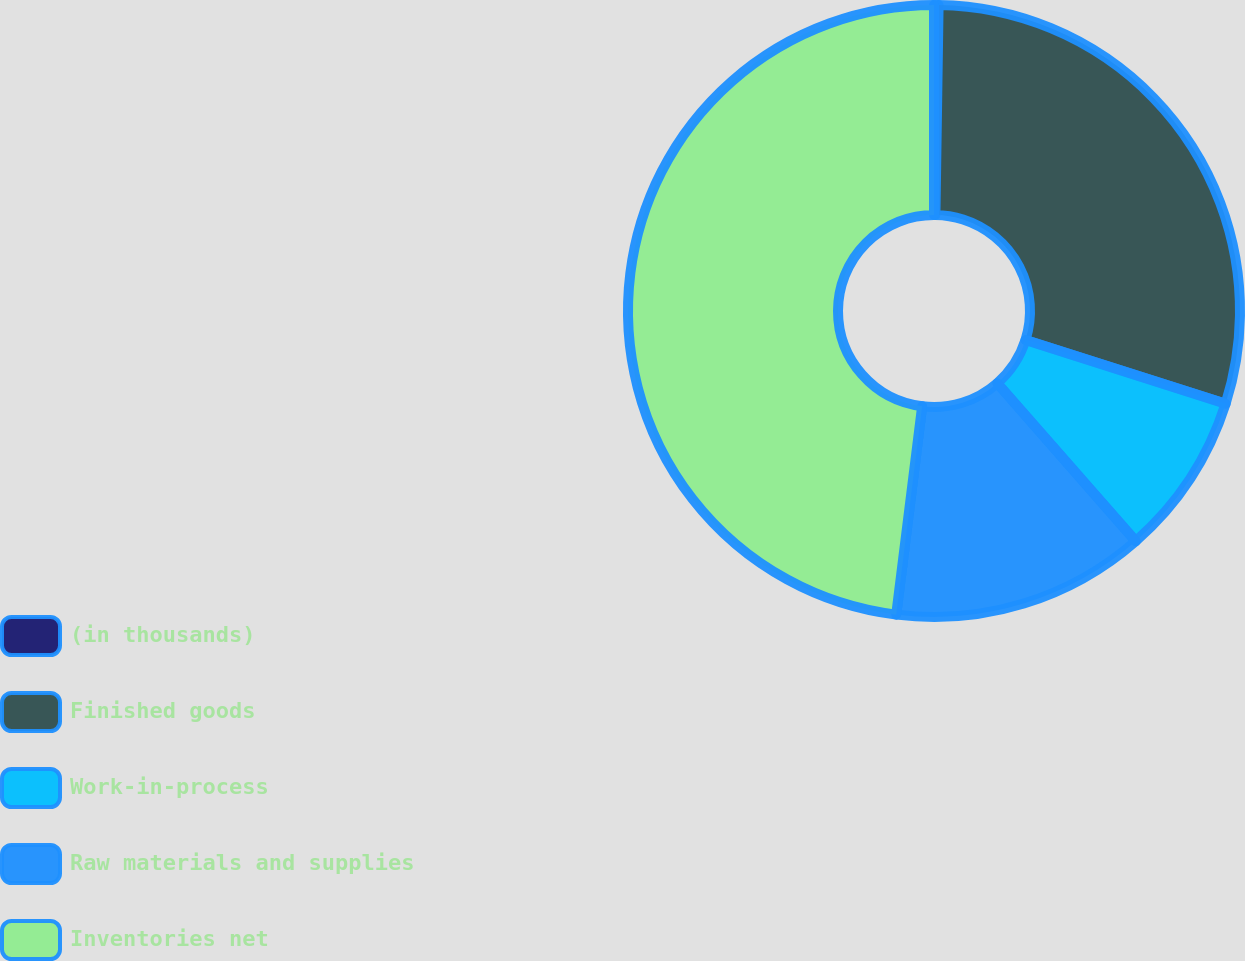<chart> <loc_0><loc_0><loc_500><loc_500><pie_chart><fcel>(in thousands)<fcel>Finished goods<fcel>Work-in-process<fcel>Raw materials and supplies<fcel>Inventories net<nl><fcel>0.24%<fcel>29.66%<fcel>8.65%<fcel>13.42%<fcel>48.03%<nl></chart> 